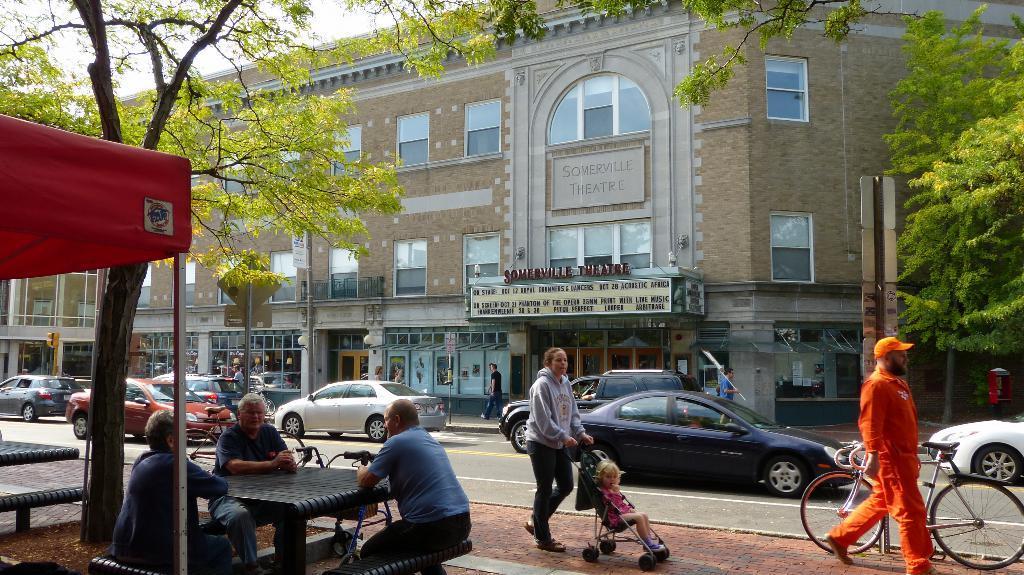In one or two sentences, can you explain what this image depicts? In this image we can see a few people, some of them are walking on the path, also we can see bicycles, there are some vehicles, on the road, there are sign boards, trees, mailbox, traffic lights, poles, there is a building, windows, and boards with some text written on it, there are some tables, benches, tent, also we can see the sky. 